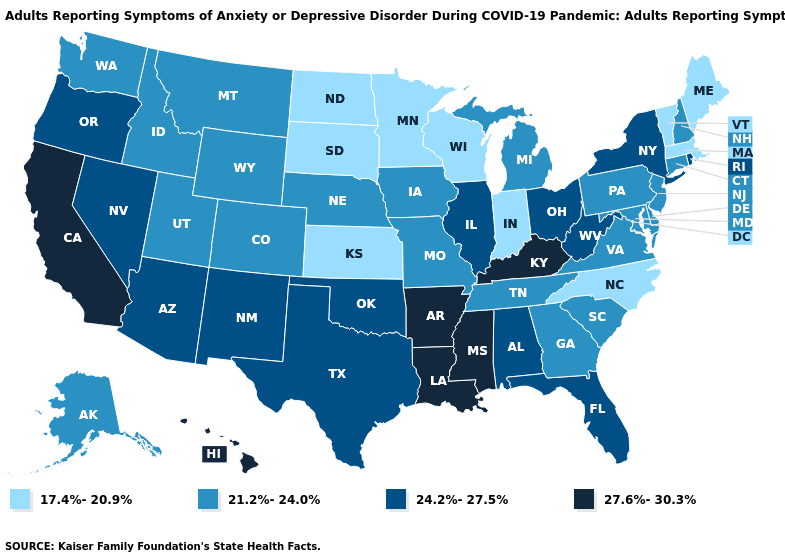Among the states that border Oregon , which have the highest value?
Keep it brief. California. What is the value of New Mexico?
Answer briefly. 24.2%-27.5%. What is the highest value in the South ?
Keep it brief. 27.6%-30.3%. Name the states that have a value in the range 17.4%-20.9%?
Keep it brief. Indiana, Kansas, Maine, Massachusetts, Minnesota, North Carolina, North Dakota, South Dakota, Vermont, Wisconsin. Does Maine have a lower value than South Dakota?
Give a very brief answer. No. Name the states that have a value in the range 21.2%-24.0%?
Quick response, please. Alaska, Colorado, Connecticut, Delaware, Georgia, Idaho, Iowa, Maryland, Michigan, Missouri, Montana, Nebraska, New Hampshire, New Jersey, Pennsylvania, South Carolina, Tennessee, Utah, Virginia, Washington, Wyoming. Name the states that have a value in the range 24.2%-27.5%?
Give a very brief answer. Alabama, Arizona, Florida, Illinois, Nevada, New Mexico, New York, Ohio, Oklahoma, Oregon, Rhode Island, Texas, West Virginia. How many symbols are there in the legend?
Be succinct. 4. Name the states that have a value in the range 21.2%-24.0%?
Write a very short answer. Alaska, Colorado, Connecticut, Delaware, Georgia, Idaho, Iowa, Maryland, Michigan, Missouri, Montana, Nebraska, New Hampshire, New Jersey, Pennsylvania, South Carolina, Tennessee, Utah, Virginia, Washington, Wyoming. Which states have the highest value in the USA?
Answer briefly. Arkansas, California, Hawaii, Kentucky, Louisiana, Mississippi. Which states have the lowest value in the South?
Quick response, please. North Carolina. Which states have the lowest value in the South?
Give a very brief answer. North Carolina. Does California have a higher value than Ohio?
Short answer required. Yes. What is the value of Iowa?
Short answer required. 21.2%-24.0%. Does Louisiana have a lower value than Nevada?
Keep it brief. No. 